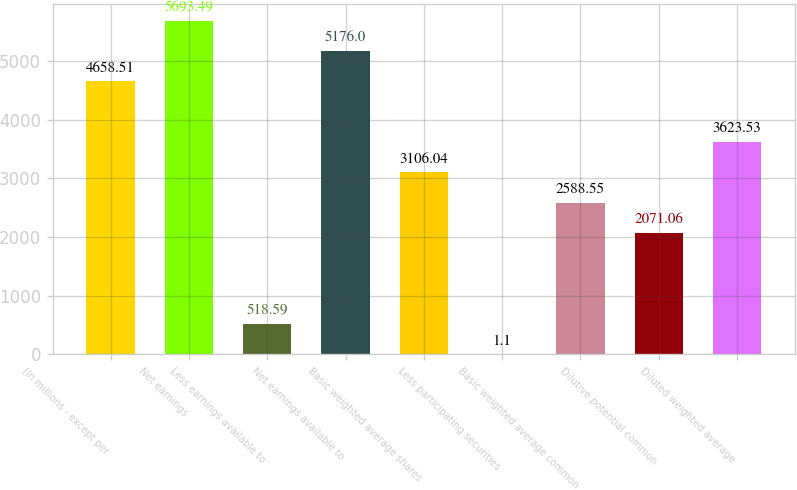Convert chart. <chart><loc_0><loc_0><loc_500><loc_500><bar_chart><fcel>(In millions - except per<fcel>Net earnings<fcel>Less earnings available to<fcel>Net earnings available to<fcel>Basic weighted average shares<fcel>Less participating securities<fcel>Basic weighted average common<fcel>Dilutive potential common<fcel>Diluted weighted average<nl><fcel>4658.51<fcel>5693.49<fcel>518.59<fcel>5176<fcel>3106.04<fcel>1.1<fcel>2588.55<fcel>2071.06<fcel>3623.53<nl></chart> 